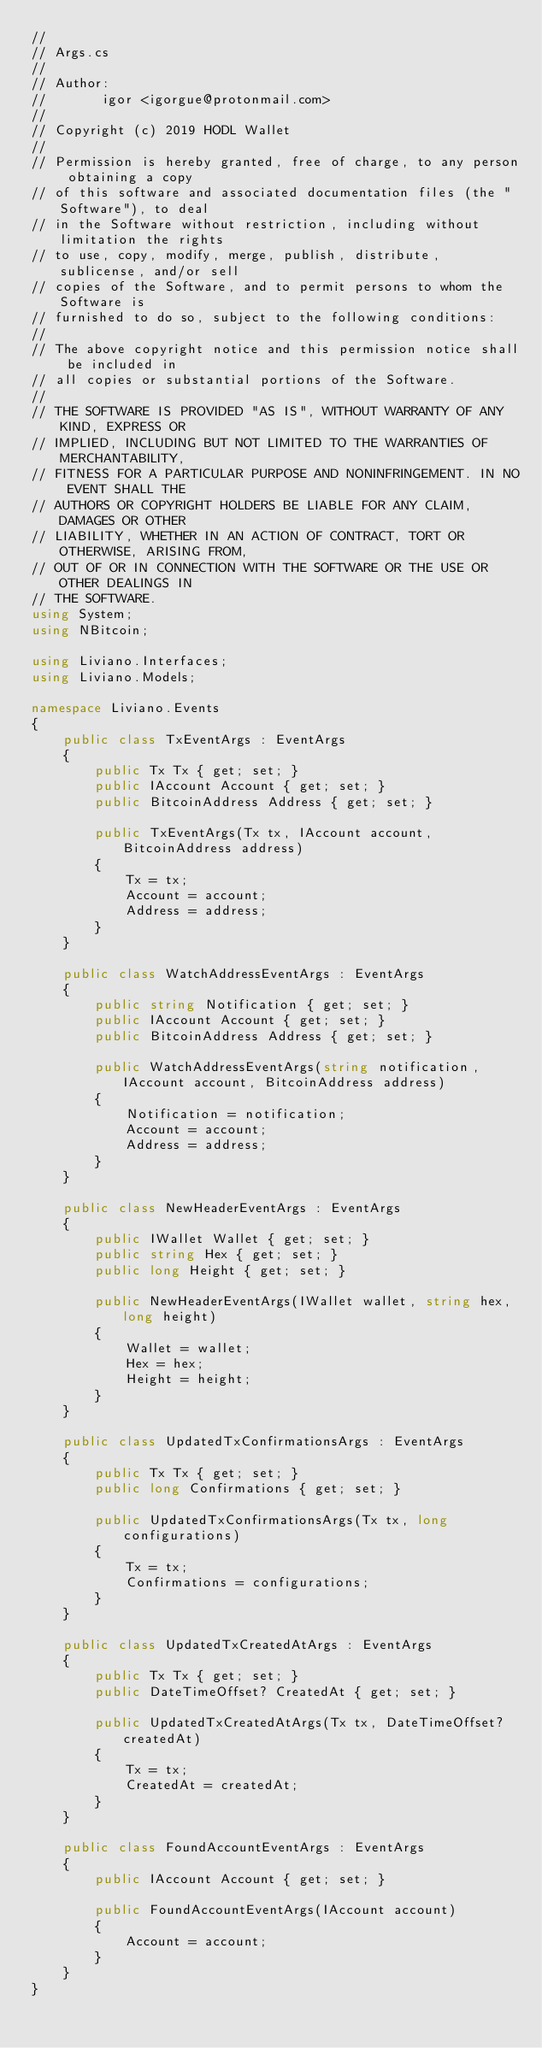Convert code to text. <code><loc_0><loc_0><loc_500><loc_500><_C#_>//
// Args.cs
//
// Author:
//       igor <igorgue@protonmail.com>
//
// Copyright (c) 2019 HODL Wallet
//
// Permission is hereby granted, free of charge, to any person obtaining a copy
// of this software and associated documentation files (the "Software"), to deal
// in the Software without restriction, including without limitation the rights
// to use, copy, modify, merge, publish, distribute, sublicense, and/or sell
// copies of the Software, and to permit persons to whom the Software is
// furnished to do so, subject to the following conditions:
//
// The above copyright notice and this permission notice shall be included in
// all copies or substantial portions of the Software.
//
// THE SOFTWARE IS PROVIDED "AS IS", WITHOUT WARRANTY OF ANY KIND, EXPRESS OR
// IMPLIED, INCLUDING BUT NOT LIMITED TO THE WARRANTIES OF MERCHANTABILITY,
// FITNESS FOR A PARTICULAR PURPOSE AND NONINFRINGEMENT. IN NO EVENT SHALL THE
// AUTHORS OR COPYRIGHT HOLDERS BE LIABLE FOR ANY CLAIM, DAMAGES OR OTHER
// LIABILITY, WHETHER IN AN ACTION OF CONTRACT, TORT OR OTHERWISE, ARISING FROM,
// OUT OF OR IN CONNECTION WITH THE SOFTWARE OR THE USE OR OTHER DEALINGS IN
// THE SOFTWARE.
using System;
using NBitcoin;

using Liviano.Interfaces;
using Liviano.Models;

namespace Liviano.Events
{
    public class TxEventArgs : EventArgs
    {
        public Tx Tx { get; set; }
        public IAccount Account { get; set; }
        public BitcoinAddress Address { get; set; }

        public TxEventArgs(Tx tx, IAccount account, BitcoinAddress address)
        {
            Tx = tx;
            Account = account;
            Address = address;
        }
    }

    public class WatchAddressEventArgs : EventArgs
    {
        public string Notification { get; set; }
        public IAccount Account { get; set; }
        public BitcoinAddress Address { get; set; }

        public WatchAddressEventArgs(string notification, IAccount account, BitcoinAddress address)
        {
            Notification = notification;
            Account = account;
            Address = address;
        }
    }

    public class NewHeaderEventArgs : EventArgs
    {
        public IWallet Wallet { get; set; }
        public string Hex { get; set; }
        public long Height { get; set; }

        public NewHeaderEventArgs(IWallet wallet, string hex, long height)
        {
            Wallet = wallet;
            Hex = hex;
            Height = height;
        }
    }

    public class UpdatedTxConfirmationsArgs : EventArgs
    {
        public Tx Tx { get; set; }
        public long Confirmations { get; set; }

        public UpdatedTxConfirmationsArgs(Tx tx, long configurations)
        {
            Tx = tx;
            Confirmations = configurations;
        }
    }

    public class UpdatedTxCreatedAtArgs : EventArgs
    {
        public Tx Tx { get; set; }
        public DateTimeOffset? CreatedAt { get; set; }

        public UpdatedTxCreatedAtArgs(Tx tx, DateTimeOffset? createdAt)
        {
            Tx = tx;
            CreatedAt = createdAt;
        }
    }

    public class FoundAccountEventArgs : EventArgs
    {
        public IAccount Account { get; set; }

        public FoundAccountEventArgs(IAccount account)
        {
            Account = account;
        }
    }
}
</code> 